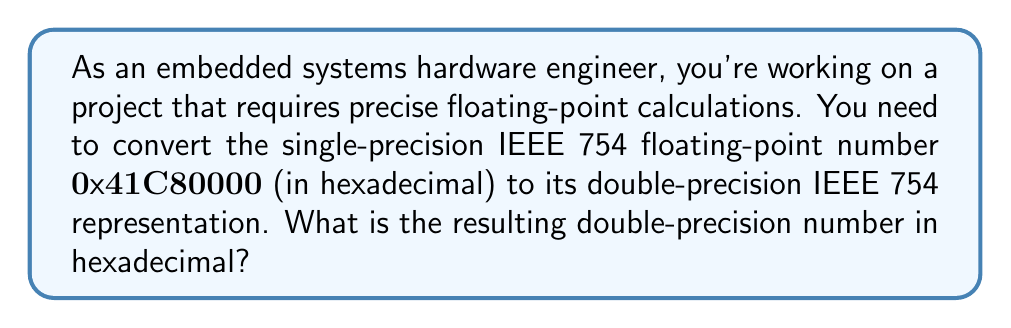Help me with this question. Let's break this down step-by-step:

1) First, let's convert the single-precision number to its binary representation:
   $0\text{x}41C80000 = 0100 0001 1100 1000 0000 0000 0000 0000$

2) In IEEE 754 single-precision format:
   - Sign bit (1 bit): 0
   - Exponent (8 bits): 10000011
   - Fraction (23 bits): 10010000000000000000000

3) Let's decode this:
   - Sign: 0 (positive)
   - Exponent: $10000011_2 = 131_{10}$. Bias is 127, so true exponent is 131 - 127 = 4
   - Fraction: $1.10010000000000000000000_2$

4) The value represented is: $1.10010000000000000000000_2 \times 2^4 = 11001.0000000000000000000_2 = 25_{10}$

5) Now, let's convert to double-precision:
   - Sign bit remains 0
   - Exponent: 4 + 1023 (new bias) = 1027 = $10000000011_2$
   - Fraction: We need to extend the fraction to 52 bits by adding zeros

6) Putting it all together in double-precision format:
   0 10000000011 1001000000000000000000000000000000000000000000000000

7) Converting to hexadecimal:
   $0100 0000 0011 1001 0000 0000 0000 0000 0000 0000 0000 0000 0000 0000$
   = $0\text{x}4039000000000000$
Answer: $0\text{x}4039000000000000$ 